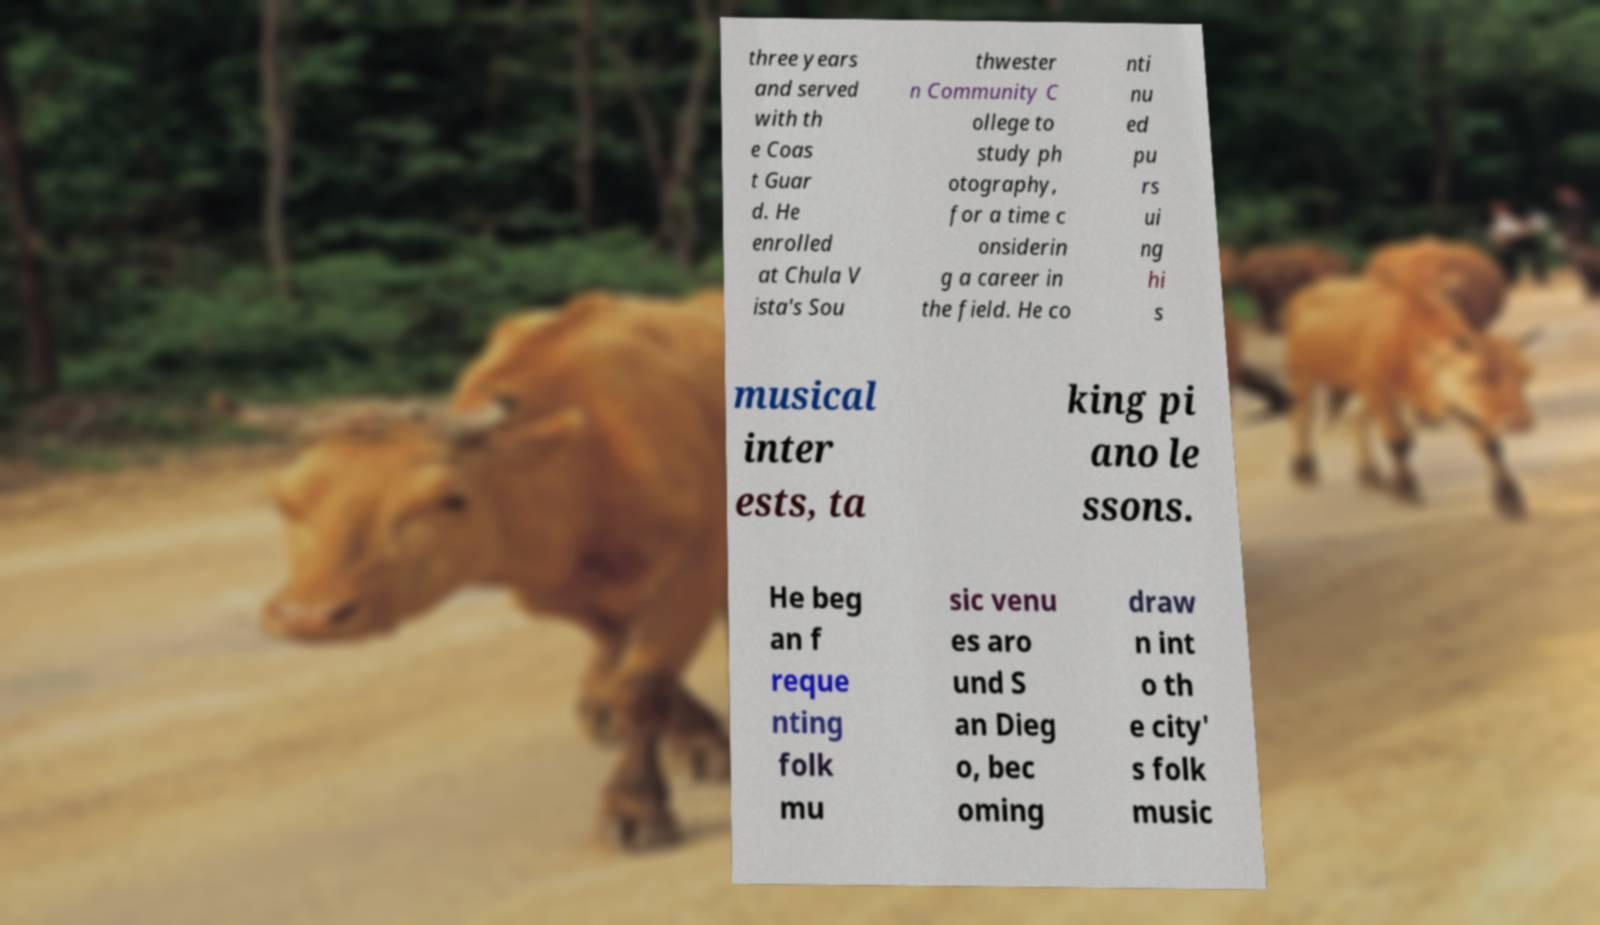Please read and relay the text visible in this image. What does it say? three years and served with th e Coas t Guar d. He enrolled at Chula V ista's Sou thwester n Community C ollege to study ph otography, for a time c onsiderin g a career in the field. He co nti nu ed pu rs ui ng hi s musical inter ests, ta king pi ano le ssons. He beg an f reque nting folk mu sic venu es aro und S an Dieg o, bec oming draw n int o th e city' s folk music 